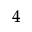<formula> <loc_0><loc_0><loc_500><loc_500>_ { 4 }</formula> 